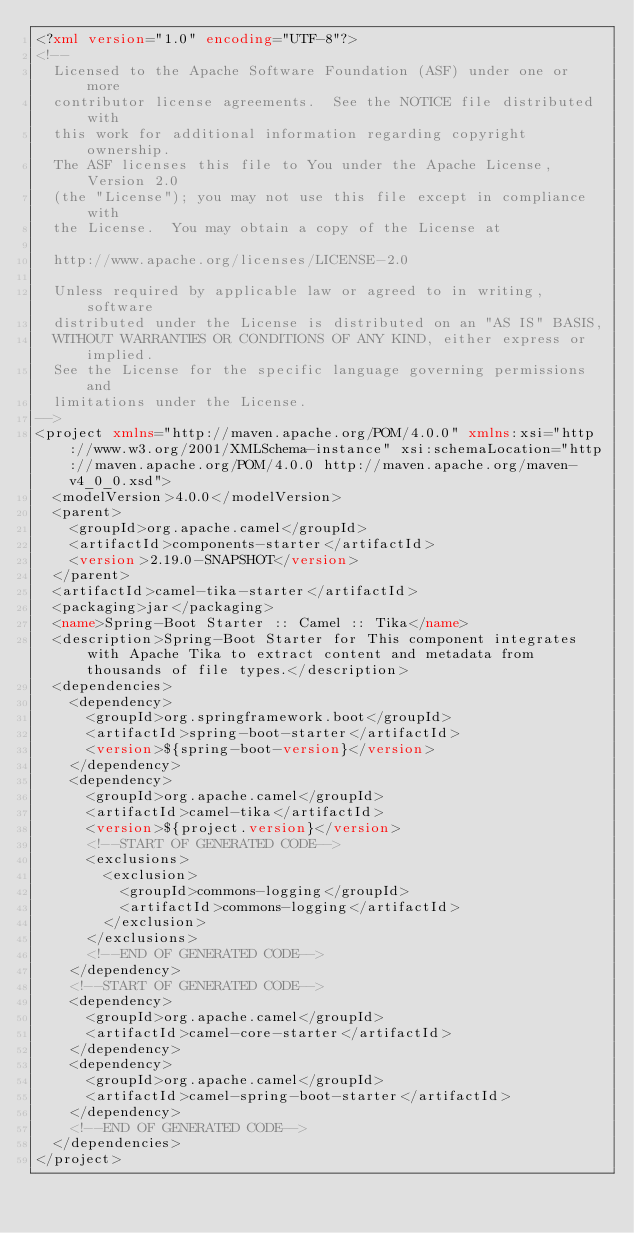Convert code to text. <code><loc_0><loc_0><loc_500><loc_500><_XML_><?xml version="1.0" encoding="UTF-8"?>
<!--
  Licensed to the Apache Software Foundation (ASF) under one or more
  contributor license agreements.  See the NOTICE file distributed with
  this work for additional information regarding copyright ownership.
  The ASF licenses this file to You under the Apache License, Version 2.0
  (the "License"); you may not use this file except in compliance with
  the License.  You may obtain a copy of the License at

  http://www.apache.org/licenses/LICENSE-2.0

  Unless required by applicable law or agreed to in writing, software
  distributed under the License is distributed on an "AS IS" BASIS,
  WITHOUT WARRANTIES OR CONDITIONS OF ANY KIND, either express or implied.
  See the License for the specific language governing permissions and
  limitations under the License.
-->
<project xmlns="http://maven.apache.org/POM/4.0.0" xmlns:xsi="http://www.w3.org/2001/XMLSchema-instance" xsi:schemaLocation="http://maven.apache.org/POM/4.0.0 http://maven.apache.org/maven-v4_0_0.xsd">
  <modelVersion>4.0.0</modelVersion>
  <parent>
    <groupId>org.apache.camel</groupId>
    <artifactId>components-starter</artifactId>
    <version>2.19.0-SNAPSHOT</version>
  </parent>
  <artifactId>camel-tika-starter</artifactId>
  <packaging>jar</packaging>
  <name>Spring-Boot Starter :: Camel :: Tika</name>
  <description>Spring-Boot Starter for This component integrates with Apache Tika to extract content and metadata from thousands of file types.</description>
  <dependencies>
    <dependency>
      <groupId>org.springframework.boot</groupId>
      <artifactId>spring-boot-starter</artifactId>
      <version>${spring-boot-version}</version>
    </dependency>
    <dependency>
      <groupId>org.apache.camel</groupId>
      <artifactId>camel-tika</artifactId>
      <version>${project.version}</version>
      <!--START OF GENERATED CODE-->
      <exclusions>
        <exclusion>
          <groupId>commons-logging</groupId>
          <artifactId>commons-logging</artifactId>
        </exclusion>
      </exclusions>
      <!--END OF GENERATED CODE-->
    </dependency>
    <!--START OF GENERATED CODE-->
    <dependency>
      <groupId>org.apache.camel</groupId>
      <artifactId>camel-core-starter</artifactId>
    </dependency>
    <dependency>
      <groupId>org.apache.camel</groupId>
      <artifactId>camel-spring-boot-starter</artifactId>
    </dependency>
    <!--END OF GENERATED CODE-->
  </dependencies>
</project>
</code> 